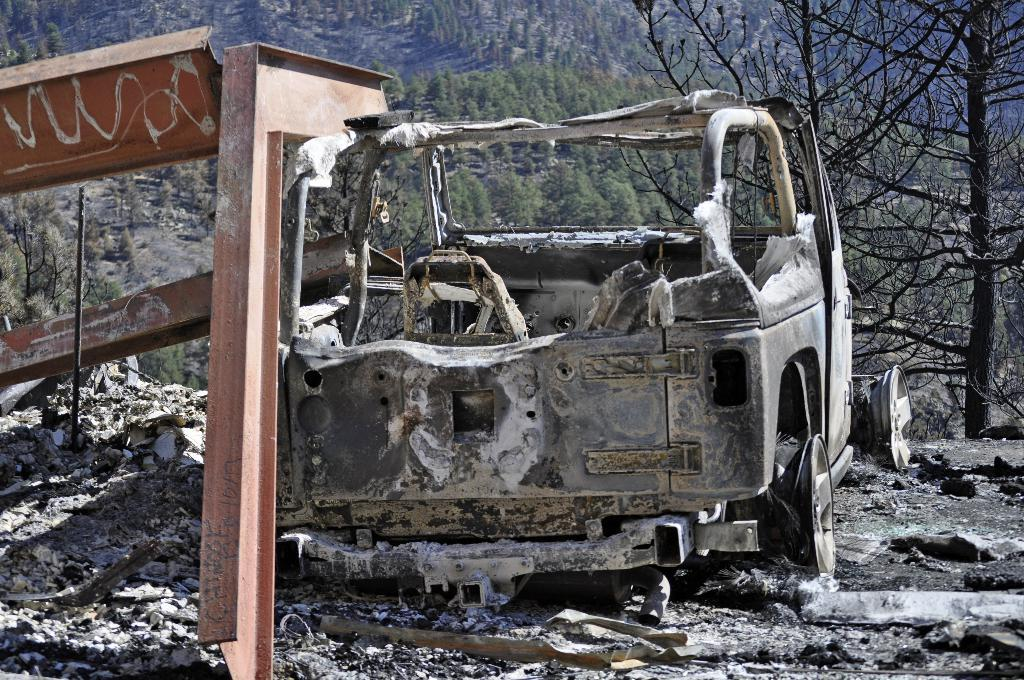What is the main subject of the image? The main subject of the image is a burned vehicle. What can be seen in the background of the image? Hills are visible in the background of the image. What type of vegetation is present on the hills? Trees are present on the hills. What type of interest can be seen growing on the burned vehicle in the image? There is no interest growing on the burned vehicle in the image. Can you see a beetle crawling on the trees in the image? There is no beetle present in the image. 